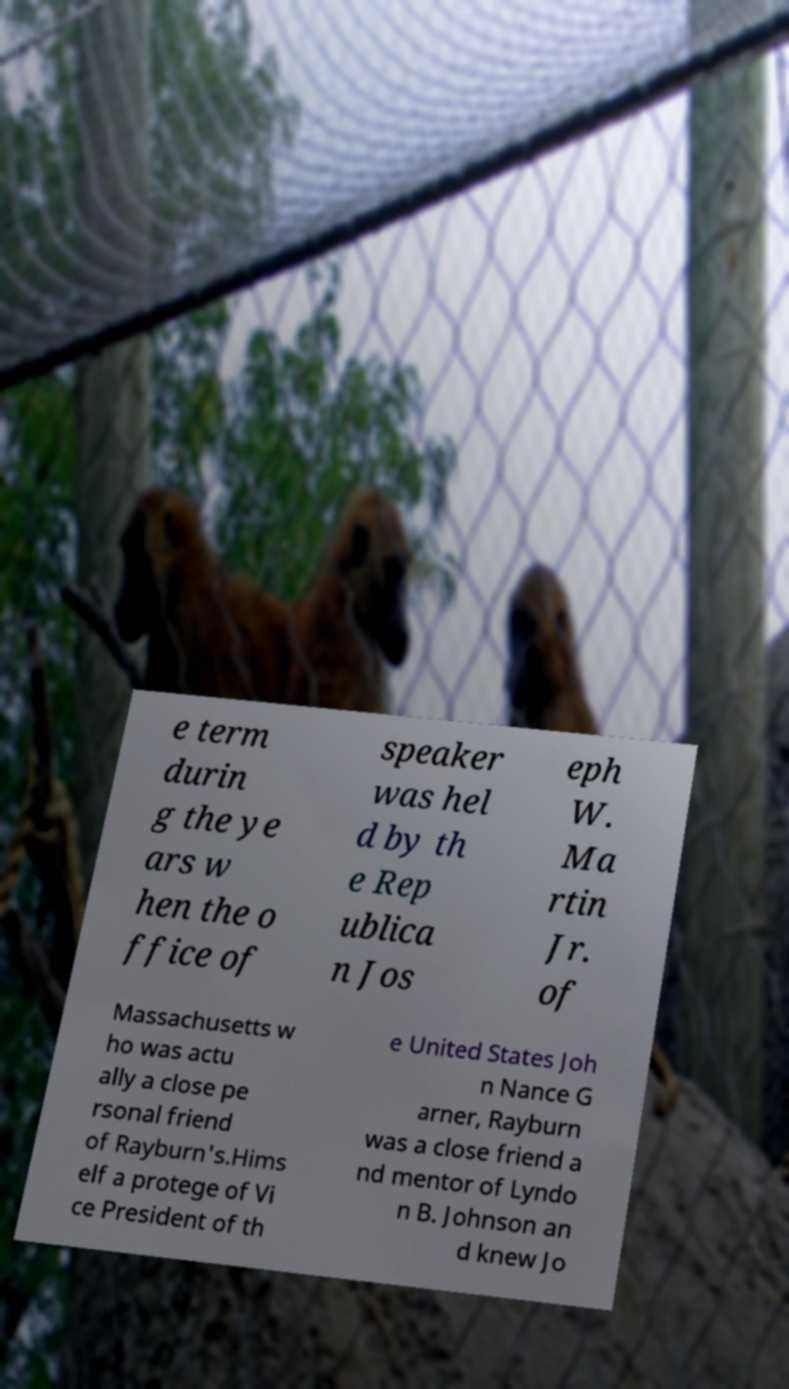What messages or text are displayed in this image? I need them in a readable, typed format. e term durin g the ye ars w hen the o ffice of speaker was hel d by th e Rep ublica n Jos eph W. Ma rtin Jr. of Massachusetts w ho was actu ally a close pe rsonal friend of Rayburn's.Hims elf a protege of Vi ce President of th e United States Joh n Nance G arner, Rayburn was a close friend a nd mentor of Lyndo n B. Johnson an d knew Jo 